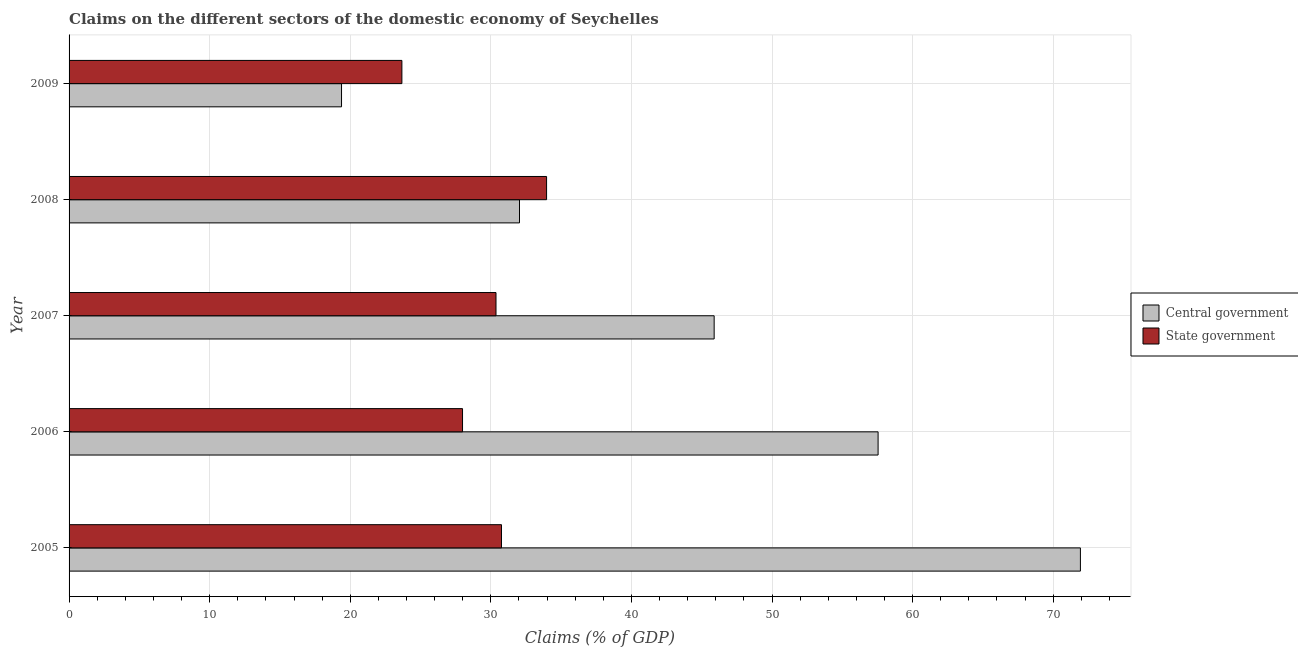Are the number of bars per tick equal to the number of legend labels?
Make the answer very short. Yes. Are the number of bars on each tick of the Y-axis equal?
Offer a very short reply. Yes. How many bars are there on the 4th tick from the top?
Offer a terse response. 2. How many bars are there on the 5th tick from the bottom?
Your answer should be very brief. 2. What is the claims on central government in 2006?
Provide a succinct answer. 57.54. Across all years, what is the maximum claims on state government?
Your answer should be very brief. 33.96. Across all years, what is the minimum claims on central government?
Keep it short and to the point. 19.38. What is the total claims on central government in the graph?
Offer a very short reply. 226.78. What is the difference between the claims on central government in 2007 and that in 2008?
Make the answer very short. 13.85. What is the difference between the claims on central government in 2007 and the claims on state government in 2006?
Provide a succinct answer. 17.9. What is the average claims on state government per year?
Provide a succinct answer. 29.35. In the year 2007, what is the difference between the claims on central government and claims on state government?
Your answer should be very brief. 15.52. What is the ratio of the claims on central government in 2006 to that in 2008?
Keep it short and to the point. 1.8. Is the claims on state government in 2005 less than that in 2007?
Offer a terse response. No. Is the difference between the claims on central government in 2007 and 2009 greater than the difference between the claims on state government in 2007 and 2009?
Provide a short and direct response. Yes. What is the difference between the highest and the second highest claims on state government?
Your answer should be compact. 3.21. What is the difference between the highest and the lowest claims on state government?
Make the answer very short. 10.29. In how many years, is the claims on state government greater than the average claims on state government taken over all years?
Your answer should be very brief. 3. What does the 2nd bar from the top in 2008 represents?
Provide a short and direct response. Central government. What does the 1st bar from the bottom in 2005 represents?
Your answer should be very brief. Central government. How many bars are there?
Make the answer very short. 10. Are all the bars in the graph horizontal?
Your answer should be very brief. Yes. What is the difference between two consecutive major ticks on the X-axis?
Keep it short and to the point. 10. Are the values on the major ticks of X-axis written in scientific E-notation?
Keep it short and to the point. No. Does the graph contain any zero values?
Ensure brevity in your answer.  No. Does the graph contain grids?
Ensure brevity in your answer.  Yes. Where does the legend appear in the graph?
Your answer should be very brief. Center right. How are the legend labels stacked?
Ensure brevity in your answer.  Vertical. What is the title of the graph?
Give a very brief answer. Claims on the different sectors of the domestic economy of Seychelles. What is the label or title of the X-axis?
Provide a succinct answer. Claims (% of GDP). What is the Claims (% of GDP) in Central government in 2005?
Ensure brevity in your answer.  71.94. What is the Claims (% of GDP) in State government in 2005?
Your response must be concise. 30.76. What is the Claims (% of GDP) of Central government in 2006?
Your response must be concise. 57.54. What is the Claims (% of GDP) in State government in 2006?
Ensure brevity in your answer.  27.99. What is the Claims (% of GDP) in Central government in 2007?
Your answer should be very brief. 45.88. What is the Claims (% of GDP) in State government in 2007?
Keep it short and to the point. 30.37. What is the Claims (% of GDP) in Central government in 2008?
Ensure brevity in your answer.  32.04. What is the Claims (% of GDP) in State government in 2008?
Offer a terse response. 33.96. What is the Claims (% of GDP) of Central government in 2009?
Your answer should be very brief. 19.38. What is the Claims (% of GDP) in State government in 2009?
Your answer should be very brief. 23.67. Across all years, what is the maximum Claims (% of GDP) of Central government?
Provide a succinct answer. 71.94. Across all years, what is the maximum Claims (% of GDP) of State government?
Ensure brevity in your answer.  33.96. Across all years, what is the minimum Claims (% of GDP) of Central government?
Your answer should be compact. 19.38. Across all years, what is the minimum Claims (% of GDP) in State government?
Offer a terse response. 23.67. What is the total Claims (% of GDP) in Central government in the graph?
Your answer should be compact. 226.78. What is the total Claims (% of GDP) in State government in the graph?
Make the answer very short. 146.75. What is the difference between the Claims (% of GDP) in Central government in 2005 and that in 2006?
Provide a short and direct response. 14.39. What is the difference between the Claims (% of GDP) in State government in 2005 and that in 2006?
Offer a terse response. 2.77. What is the difference between the Claims (% of GDP) of Central government in 2005 and that in 2007?
Offer a terse response. 26.05. What is the difference between the Claims (% of GDP) in State government in 2005 and that in 2007?
Provide a succinct answer. 0.39. What is the difference between the Claims (% of GDP) of Central government in 2005 and that in 2008?
Make the answer very short. 39.9. What is the difference between the Claims (% of GDP) of State government in 2005 and that in 2008?
Keep it short and to the point. -3.21. What is the difference between the Claims (% of GDP) in Central government in 2005 and that in 2009?
Make the answer very short. 52.56. What is the difference between the Claims (% of GDP) of State government in 2005 and that in 2009?
Offer a terse response. 7.08. What is the difference between the Claims (% of GDP) of Central government in 2006 and that in 2007?
Offer a terse response. 11.66. What is the difference between the Claims (% of GDP) of State government in 2006 and that in 2007?
Give a very brief answer. -2.38. What is the difference between the Claims (% of GDP) in Central government in 2006 and that in 2008?
Offer a terse response. 25.51. What is the difference between the Claims (% of GDP) of State government in 2006 and that in 2008?
Ensure brevity in your answer.  -5.98. What is the difference between the Claims (% of GDP) of Central government in 2006 and that in 2009?
Your answer should be compact. 38.16. What is the difference between the Claims (% of GDP) in State government in 2006 and that in 2009?
Your answer should be compact. 4.31. What is the difference between the Claims (% of GDP) of Central government in 2007 and that in 2008?
Your answer should be very brief. 13.85. What is the difference between the Claims (% of GDP) in State government in 2007 and that in 2008?
Keep it short and to the point. -3.6. What is the difference between the Claims (% of GDP) in Central government in 2007 and that in 2009?
Keep it short and to the point. 26.5. What is the difference between the Claims (% of GDP) of State government in 2007 and that in 2009?
Your response must be concise. 6.69. What is the difference between the Claims (% of GDP) of Central government in 2008 and that in 2009?
Your answer should be compact. 12.66. What is the difference between the Claims (% of GDP) of State government in 2008 and that in 2009?
Provide a succinct answer. 10.29. What is the difference between the Claims (% of GDP) in Central government in 2005 and the Claims (% of GDP) in State government in 2006?
Give a very brief answer. 43.95. What is the difference between the Claims (% of GDP) in Central government in 2005 and the Claims (% of GDP) in State government in 2007?
Make the answer very short. 41.57. What is the difference between the Claims (% of GDP) of Central government in 2005 and the Claims (% of GDP) of State government in 2008?
Make the answer very short. 37.97. What is the difference between the Claims (% of GDP) of Central government in 2005 and the Claims (% of GDP) of State government in 2009?
Offer a terse response. 48.26. What is the difference between the Claims (% of GDP) in Central government in 2006 and the Claims (% of GDP) in State government in 2007?
Ensure brevity in your answer.  27.18. What is the difference between the Claims (% of GDP) in Central government in 2006 and the Claims (% of GDP) in State government in 2008?
Provide a short and direct response. 23.58. What is the difference between the Claims (% of GDP) in Central government in 2006 and the Claims (% of GDP) in State government in 2009?
Offer a very short reply. 33.87. What is the difference between the Claims (% of GDP) of Central government in 2007 and the Claims (% of GDP) of State government in 2008?
Provide a short and direct response. 11.92. What is the difference between the Claims (% of GDP) of Central government in 2007 and the Claims (% of GDP) of State government in 2009?
Provide a short and direct response. 22.21. What is the difference between the Claims (% of GDP) of Central government in 2008 and the Claims (% of GDP) of State government in 2009?
Offer a terse response. 8.37. What is the average Claims (% of GDP) in Central government per year?
Your response must be concise. 45.36. What is the average Claims (% of GDP) in State government per year?
Give a very brief answer. 29.35. In the year 2005, what is the difference between the Claims (% of GDP) in Central government and Claims (% of GDP) in State government?
Offer a terse response. 41.18. In the year 2006, what is the difference between the Claims (% of GDP) of Central government and Claims (% of GDP) of State government?
Keep it short and to the point. 29.56. In the year 2007, what is the difference between the Claims (% of GDP) in Central government and Claims (% of GDP) in State government?
Make the answer very short. 15.52. In the year 2008, what is the difference between the Claims (% of GDP) in Central government and Claims (% of GDP) in State government?
Keep it short and to the point. -1.93. In the year 2009, what is the difference between the Claims (% of GDP) of Central government and Claims (% of GDP) of State government?
Offer a very short reply. -4.29. What is the ratio of the Claims (% of GDP) in Central government in 2005 to that in 2006?
Give a very brief answer. 1.25. What is the ratio of the Claims (% of GDP) in State government in 2005 to that in 2006?
Your answer should be very brief. 1.1. What is the ratio of the Claims (% of GDP) of Central government in 2005 to that in 2007?
Offer a very short reply. 1.57. What is the ratio of the Claims (% of GDP) of State government in 2005 to that in 2007?
Your response must be concise. 1.01. What is the ratio of the Claims (% of GDP) in Central government in 2005 to that in 2008?
Give a very brief answer. 2.25. What is the ratio of the Claims (% of GDP) in State government in 2005 to that in 2008?
Make the answer very short. 0.91. What is the ratio of the Claims (% of GDP) in Central government in 2005 to that in 2009?
Offer a terse response. 3.71. What is the ratio of the Claims (% of GDP) in State government in 2005 to that in 2009?
Your answer should be very brief. 1.3. What is the ratio of the Claims (% of GDP) of Central government in 2006 to that in 2007?
Provide a short and direct response. 1.25. What is the ratio of the Claims (% of GDP) in State government in 2006 to that in 2007?
Your response must be concise. 0.92. What is the ratio of the Claims (% of GDP) in Central government in 2006 to that in 2008?
Give a very brief answer. 1.8. What is the ratio of the Claims (% of GDP) of State government in 2006 to that in 2008?
Provide a short and direct response. 0.82. What is the ratio of the Claims (% of GDP) of Central government in 2006 to that in 2009?
Provide a short and direct response. 2.97. What is the ratio of the Claims (% of GDP) of State government in 2006 to that in 2009?
Make the answer very short. 1.18. What is the ratio of the Claims (% of GDP) in Central government in 2007 to that in 2008?
Make the answer very short. 1.43. What is the ratio of the Claims (% of GDP) in State government in 2007 to that in 2008?
Provide a succinct answer. 0.89. What is the ratio of the Claims (% of GDP) in Central government in 2007 to that in 2009?
Make the answer very short. 2.37. What is the ratio of the Claims (% of GDP) in State government in 2007 to that in 2009?
Your answer should be compact. 1.28. What is the ratio of the Claims (% of GDP) in Central government in 2008 to that in 2009?
Keep it short and to the point. 1.65. What is the ratio of the Claims (% of GDP) of State government in 2008 to that in 2009?
Offer a terse response. 1.43. What is the difference between the highest and the second highest Claims (% of GDP) in Central government?
Your answer should be compact. 14.39. What is the difference between the highest and the second highest Claims (% of GDP) of State government?
Give a very brief answer. 3.21. What is the difference between the highest and the lowest Claims (% of GDP) of Central government?
Offer a very short reply. 52.56. What is the difference between the highest and the lowest Claims (% of GDP) of State government?
Offer a very short reply. 10.29. 